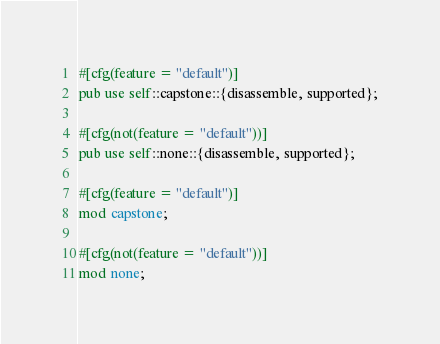<code> <loc_0><loc_0><loc_500><loc_500><_Rust_>#[cfg(feature = "default")]
pub use self::capstone::{disassemble, supported};

#[cfg(not(feature = "default"))]
pub use self::none::{disassemble, supported};

#[cfg(feature = "default")]
mod capstone;

#[cfg(not(feature = "default"))]
mod none;
</code> 